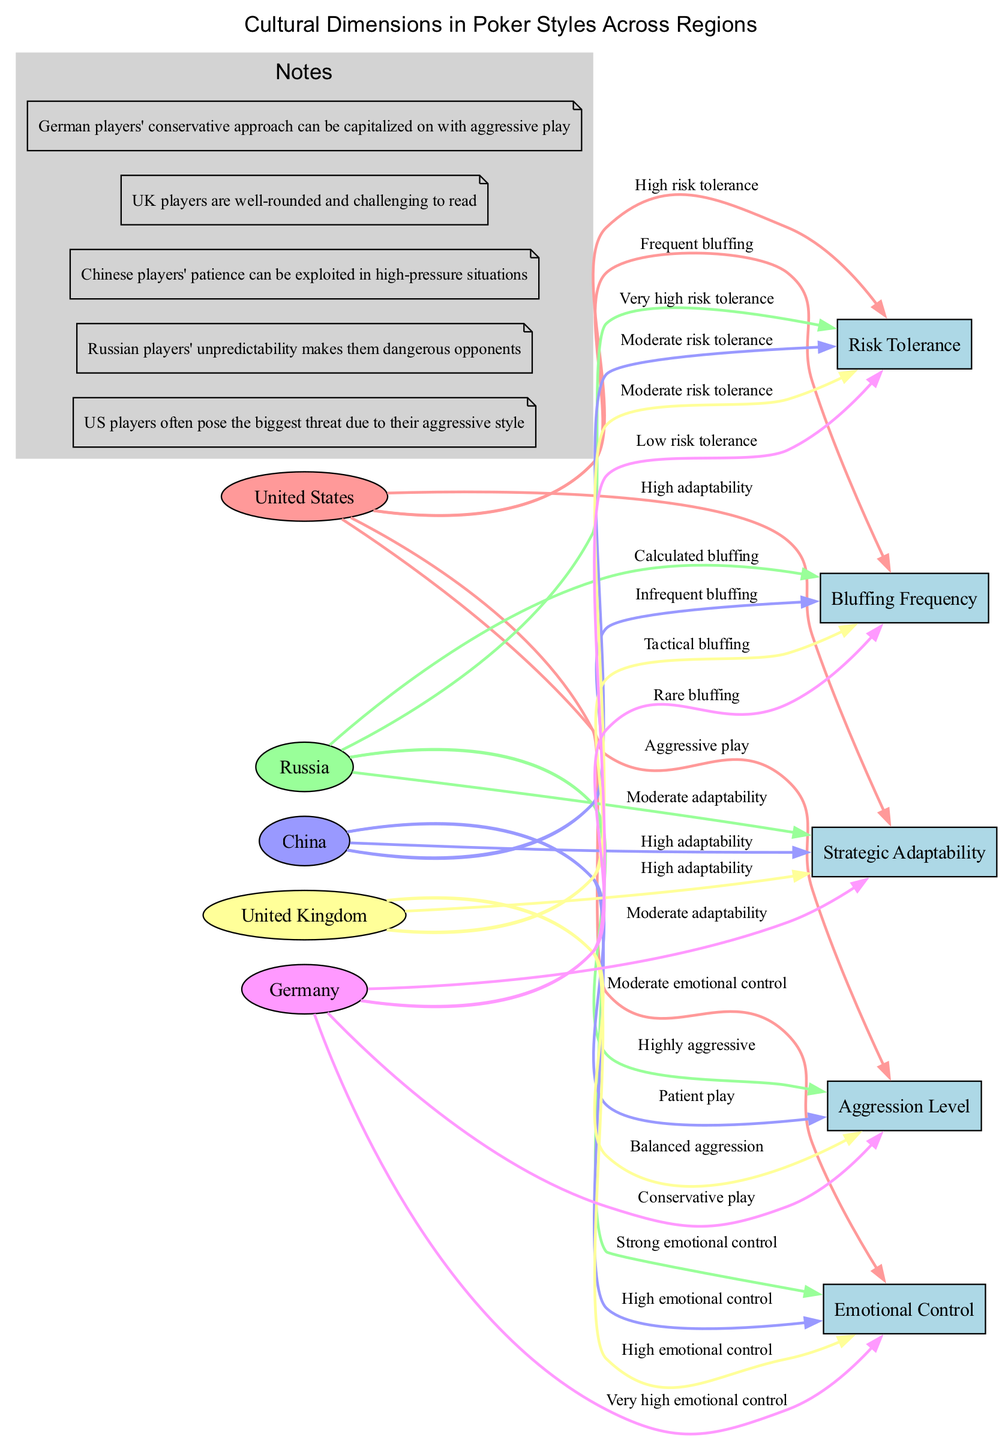What is the risk tolerance level of Russian players? According to the diagram, Russian players have "Very high risk tolerance." This trait is directly associated with the "Risk Tolerance" dimension for the "Russia" region.
Answer: Very high risk tolerance Which region has the highest aggression level? From the comparisons in the diagram, the "United States" region has "Aggressive play," which is labeled under the "Aggression Level" dimension. This indicates that US players are recognized for their aggressive approach compared to other regions.
Answer: United States How many regions are represented in the diagram? The diagram lists five regions: United States, Russia, China, United Kingdom, and Germany. This is a simple count of the unique regions presented within the diagram.
Answer: Five How do German players approach bluffing? The diagram indicates that German players have "Rare bluffing," which describes their behavior concerning the "Bluffing Frequency" dimension. This suggests a conservative and cautious strategy regarding bluffing in their gameplay.
Answer: Rare bluffing Which region exhibits the most balanced emotional control? The diagram shows that both United Kingdom and China exhibit "High emotional control." However, the UK players are noted for possessing this balance while also being adaptable, making them well-rounded opponents.
Answer: United Kingdom How does the risk tolerance of Chinese players compare to that of German players? The information presented in the diagram states that Chinese players have "Moderate risk tolerance," while German players have "Low risk tolerance." Therefore, Chinese players are more willing to take on some level of risk than their German counterparts.
Answer: Higher What is the common characteristic of UK players' bluffing style? According to the diagram, UK players use "Tactical bluffing," which implies that their bluffing is strategic rather than frequent or sporadic, showcasing their thoughtful approach in gameplay.
Answer: Tactical bluffing In which country do players exhibit the lowest emotional control? The diagram does not state that any region exhibits lower emotional control than another specifically. However, it notes that German players have "Very high emotional control," which indicates that other regions have lower emotional control comparatively. Analyzing the context, it appears that US players may have the lowest emotional control among the ones listed.
Answer: United States Which country is suggested to be the most unpredictable in terms of play style? The diagram notes that "Russian players' unpredictability makes them dangerous opponents." This statement directly ties the characteristic of unpredictability to the Russian players' style in the context of poker.
Answer: Russia 